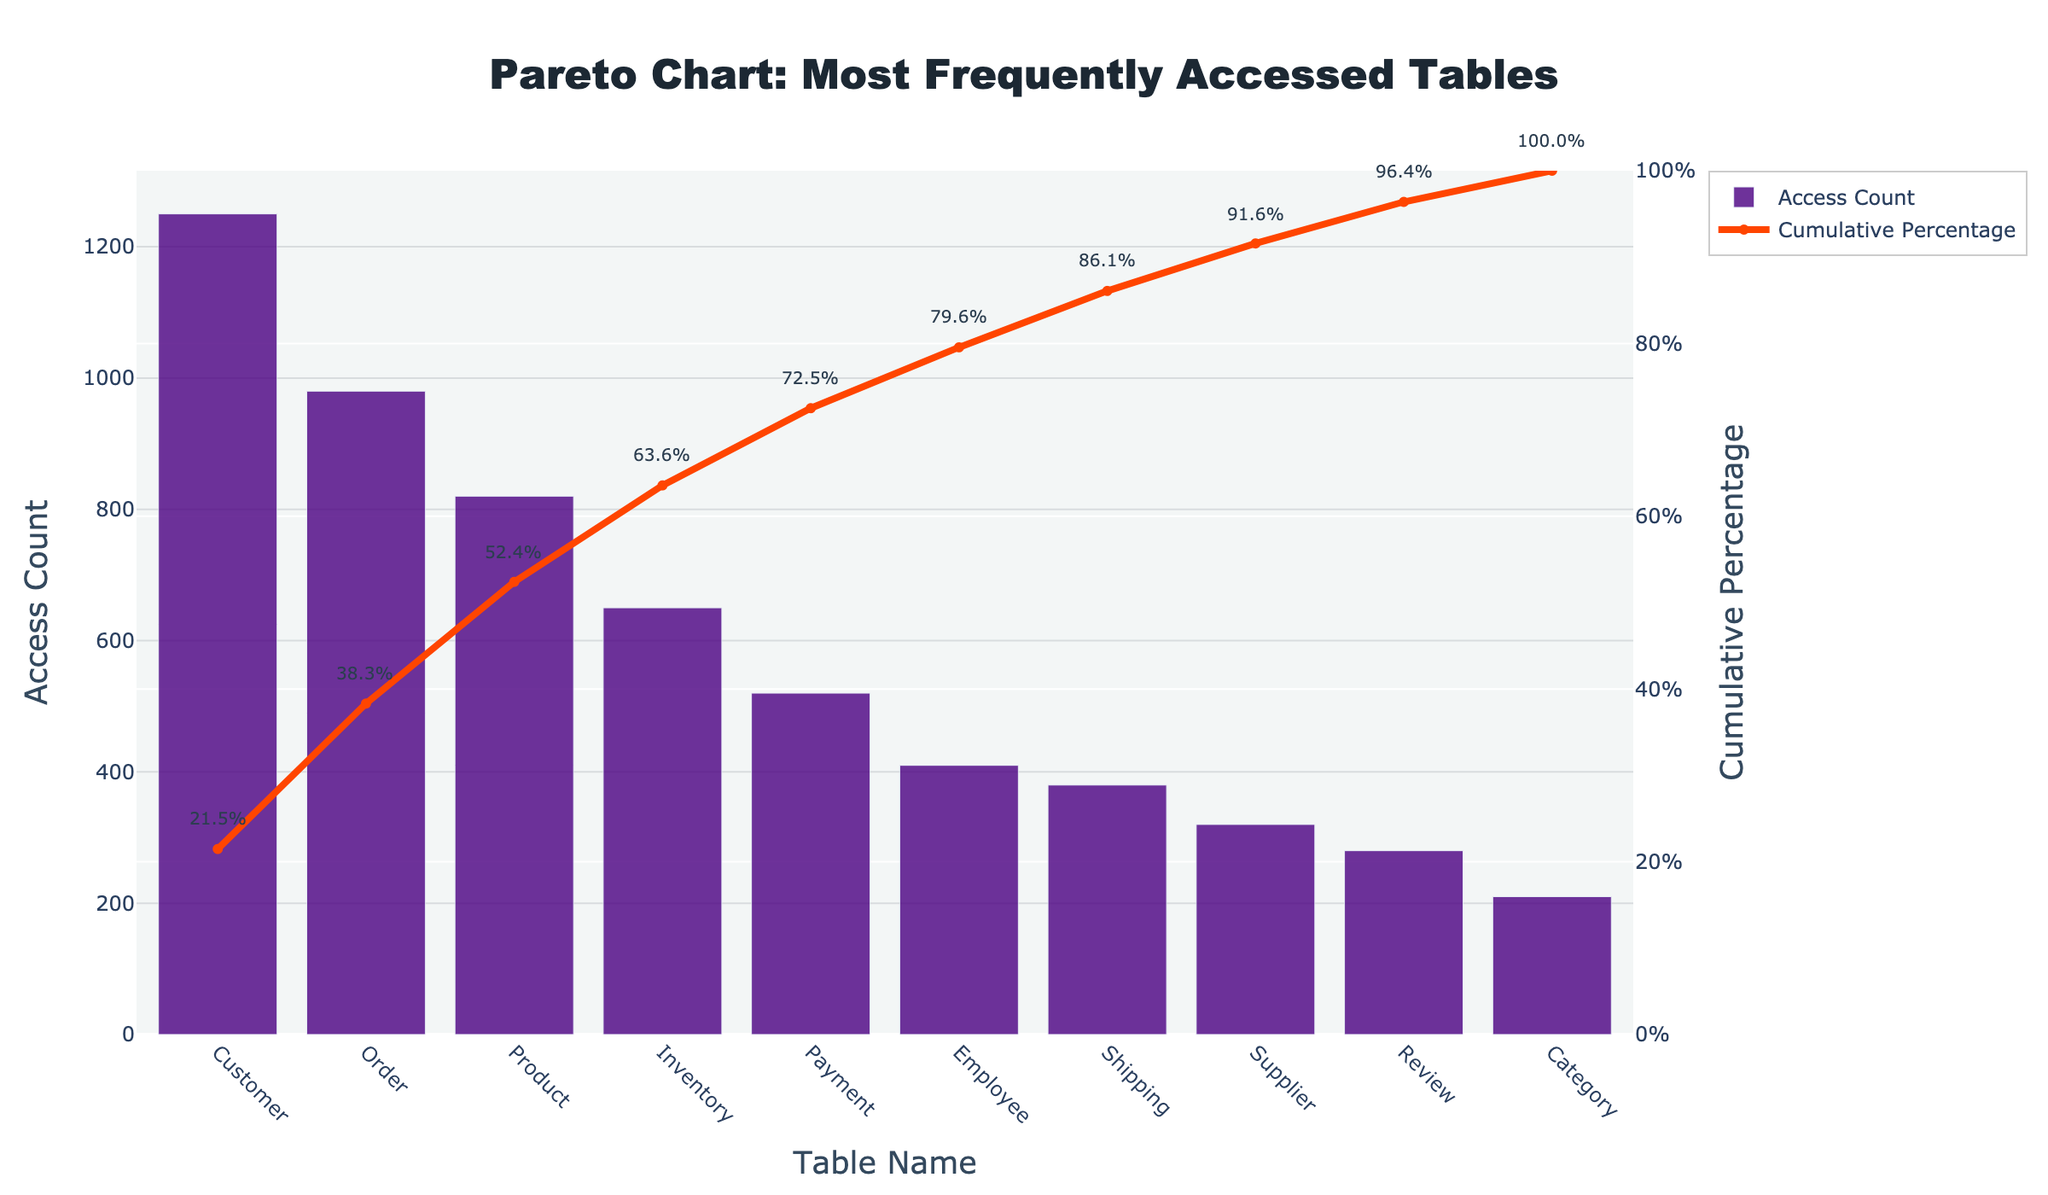what is the title of the chart? The title is displayed at the top of the chart. It reads "Pareto Chart: Most Frequently Accessed Tables."
Answer: Pareto Chart: Most Frequently Accessed Tables What is the access count for the "Order" table? The bar for the "Order" table indicates its height along the y-axis ("Access Count"), which is marked at 980.
Answer: 980 Which table has the highest access count? Among the tables listed, the "Customer" table has the highest bar, indicating its access count is the greatest.
Answer: Customer What is the cumulative percentage for the "Product" table? The line graph corresponding to the "Product" table rises to a point that aligns with the "Cumulative Percentage" axis on the right, showing around 66.2%.
Answer: 66.2% How many tables have an access count greater than 500? By checking each bar's height and comparing it to the 500 mark on the y-axis, there's a total of 4 tables: "Customer," "Order," "Product," and "Inventory."
Answer: 4 What is the sum of access counts for the "Customer" and "Order" tables? Add the access count for "Customer" (1250) and "Order" (980): 1250 + 980 = 2230.
Answer: 2230 Which table has a lower cumulative percentage than the "Employee" table? The "Review" table shows a cumulative percentage lower than the "Employee" table when observing the line graph visually.
Answer: Review What rank in access count does the "Shipping" table hold among the listed tables? By visually sorting the bar heights from highest to lowest, the "Shipping" table stands 7th in the order.
Answer: 7th Between "Payment" and "Supplier," which table has a higher access count? Comparing the bar heights for both, the "Payment" table has a higher access count at 520 versus 320 for "Supplier".
Answer: Payment Does the "Cumulative Percentage" line ever exceed 100%? The "Cumulative Percentage" line, which refers to the secondary y-axis on the right, never surpasses the 100% mark; it adheres to percentages.
Answer: No 